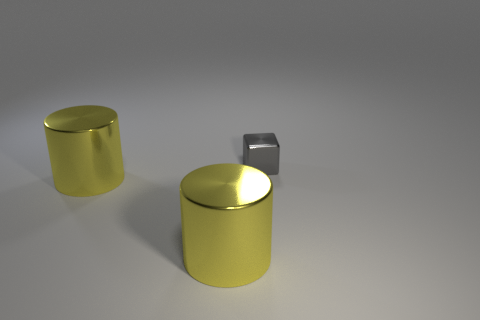Add 2 gray shiny objects. How many objects exist? 5 Subtract all cubes. How many objects are left? 2 Subtract all brown blocks. Subtract all purple cylinders. How many blocks are left? 1 Subtract all gray blocks. How many cyan cylinders are left? 0 Subtract all metallic blocks. Subtract all purple spheres. How many objects are left? 2 Add 3 gray objects. How many gray objects are left? 4 Add 2 tiny gray things. How many tiny gray things exist? 3 Subtract 0 gray spheres. How many objects are left? 3 